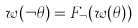Convert formula to latex. <formula><loc_0><loc_0><loc_500><loc_500>w ( \neg \theta ) = F _ { \neg } ( w ( \theta ) )</formula> 